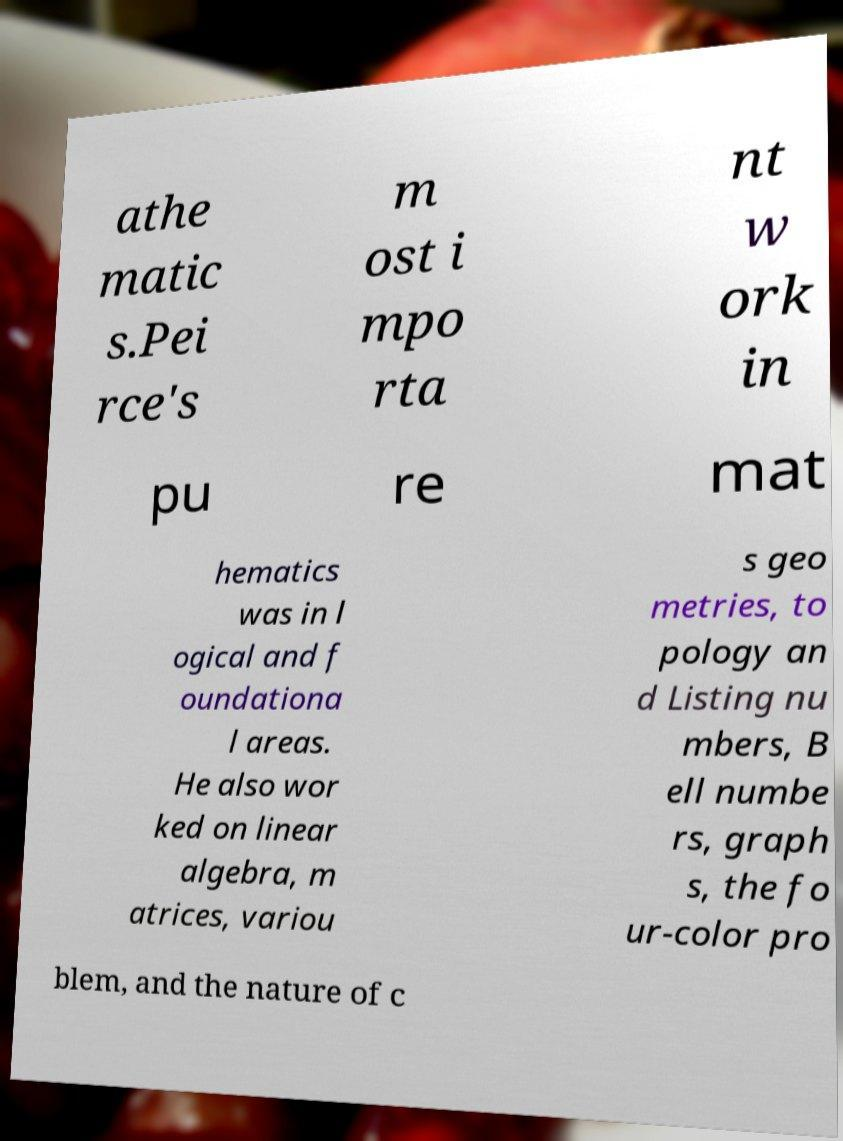Please identify and transcribe the text found in this image. athe matic s.Pei rce's m ost i mpo rta nt w ork in pu re mat hematics was in l ogical and f oundationa l areas. He also wor ked on linear algebra, m atrices, variou s geo metries, to pology an d Listing nu mbers, B ell numbe rs, graph s, the fo ur-color pro blem, and the nature of c 